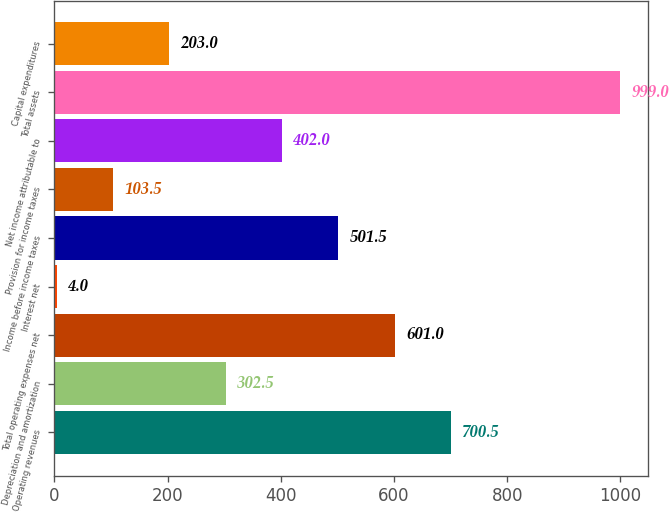<chart> <loc_0><loc_0><loc_500><loc_500><bar_chart><fcel>Operating revenues<fcel>Depreciation and amortization<fcel>Total operating expenses net<fcel>Interest net<fcel>Income before income taxes<fcel>Provision for income taxes<fcel>Net income attributable to<fcel>Total assets<fcel>Capital expenditures<nl><fcel>700.5<fcel>302.5<fcel>601<fcel>4<fcel>501.5<fcel>103.5<fcel>402<fcel>999<fcel>203<nl></chart> 